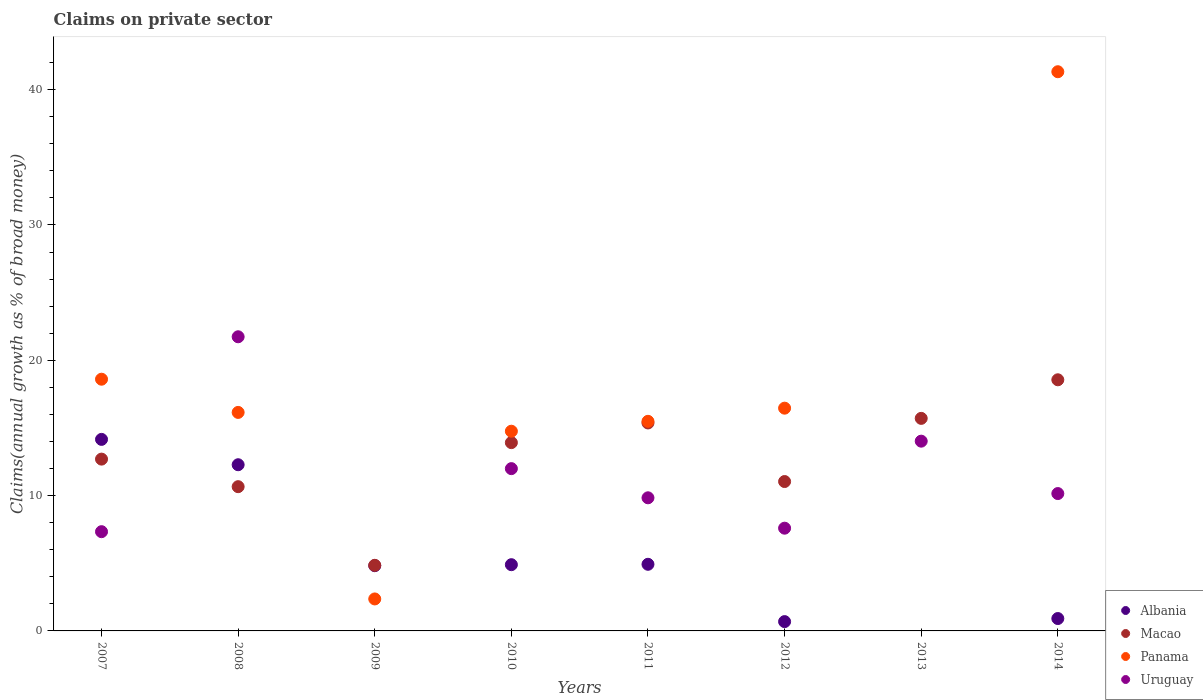What is the percentage of broad money claimed on private sector in Albania in 2014?
Keep it short and to the point. 0.92. Across all years, what is the maximum percentage of broad money claimed on private sector in Panama?
Keep it short and to the point. 41.32. Across all years, what is the minimum percentage of broad money claimed on private sector in Albania?
Ensure brevity in your answer.  0. In which year was the percentage of broad money claimed on private sector in Panama maximum?
Provide a short and direct response. 2014. What is the total percentage of broad money claimed on private sector in Albania in the graph?
Your answer should be very brief. 42.68. What is the difference between the percentage of broad money claimed on private sector in Macao in 2009 and that in 2011?
Provide a succinct answer. -10.52. What is the difference between the percentage of broad money claimed on private sector in Uruguay in 2012 and the percentage of broad money claimed on private sector in Albania in 2010?
Offer a terse response. 2.7. What is the average percentage of broad money claimed on private sector in Albania per year?
Make the answer very short. 5.33. In the year 2008, what is the difference between the percentage of broad money claimed on private sector in Uruguay and percentage of broad money claimed on private sector in Albania?
Ensure brevity in your answer.  9.46. In how many years, is the percentage of broad money claimed on private sector in Albania greater than 28 %?
Your response must be concise. 0. What is the ratio of the percentage of broad money claimed on private sector in Albania in 2009 to that in 2014?
Ensure brevity in your answer.  5.27. Is the percentage of broad money claimed on private sector in Panama in 2011 less than that in 2014?
Offer a terse response. Yes. What is the difference between the highest and the second highest percentage of broad money claimed on private sector in Albania?
Keep it short and to the point. 1.87. What is the difference between the highest and the lowest percentage of broad money claimed on private sector in Albania?
Give a very brief answer. 14.15. Does the percentage of broad money claimed on private sector in Albania monotonically increase over the years?
Your answer should be compact. No. Is the percentage of broad money claimed on private sector in Uruguay strictly less than the percentage of broad money claimed on private sector in Albania over the years?
Provide a succinct answer. No. How many years are there in the graph?
Ensure brevity in your answer.  8. Does the graph contain any zero values?
Provide a succinct answer. Yes. Does the graph contain grids?
Make the answer very short. No. How are the legend labels stacked?
Make the answer very short. Vertical. What is the title of the graph?
Provide a short and direct response. Claims on private sector. Does "Uruguay" appear as one of the legend labels in the graph?
Offer a terse response. Yes. What is the label or title of the Y-axis?
Your answer should be very brief. Claims(annual growth as % of broad money). What is the Claims(annual growth as % of broad money) in Albania in 2007?
Provide a succinct answer. 14.15. What is the Claims(annual growth as % of broad money) of Macao in 2007?
Keep it short and to the point. 12.7. What is the Claims(annual growth as % of broad money) of Panama in 2007?
Provide a succinct answer. 18.6. What is the Claims(annual growth as % of broad money) in Uruguay in 2007?
Your answer should be very brief. 7.33. What is the Claims(annual growth as % of broad money) of Albania in 2008?
Provide a short and direct response. 12.28. What is the Claims(annual growth as % of broad money) in Macao in 2008?
Keep it short and to the point. 10.66. What is the Claims(annual growth as % of broad money) of Panama in 2008?
Your answer should be compact. 16.15. What is the Claims(annual growth as % of broad money) of Uruguay in 2008?
Provide a succinct answer. 21.74. What is the Claims(annual growth as % of broad money) in Albania in 2009?
Give a very brief answer. 4.82. What is the Claims(annual growth as % of broad money) in Macao in 2009?
Give a very brief answer. 4.85. What is the Claims(annual growth as % of broad money) of Panama in 2009?
Offer a very short reply. 2.36. What is the Claims(annual growth as % of broad money) of Albania in 2010?
Your answer should be very brief. 4.89. What is the Claims(annual growth as % of broad money) in Macao in 2010?
Provide a short and direct response. 13.91. What is the Claims(annual growth as % of broad money) of Panama in 2010?
Provide a short and direct response. 14.76. What is the Claims(annual growth as % of broad money) of Uruguay in 2010?
Make the answer very short. 11.99. What is the Claims(annual growth as % of broad money) of Albania in 2011?
Keep it short and to the point. 4.92. What is the Claims(annual growth as % of broad money) in Macao in 2011?
Offer a terse response. 15.37. What is the Claims(annual growth as % of broad money) in Panama in 2011?
Make the answer very short. 15.49. What is the Claims(annual growth as % of broad money) in Uruguay in 2011?
Offer a very short reply. 9.84. What is the Claims(annual growth as % of broad money) of Albania in 2012?
Make the answer very short. 0.69. What is the Claims(annual growth as % of broad money) in Macao in 2012?
Your response must be concise. 11.04. What is the Claims(annual growth as % of broad money) of Panama in 2012?
Provide a succinct answer. 16.46. What is the Claims(annual growth as % of broad money) of Uruguay in 2012?
Ensure brevity in your answer.  7.59. What is the Claims(annual growth as % of broad money) of Albania in 2013?
Give a very brief answer. 0. What is the Claims(annual growth as % of broad money) in Macao in 2013?
Your response must be concise. 15.71. What is the Claims(annual growth as % of broad money) of Uruguay in 2013?
Your answer should be compact. 14.02. What is the Claims(annual growth as % of broad money) of Albania in 2014?
Your answer should be compact. 0.92. What is the Claims(annual growth as % of broad money) in Macao in 2014?
Give a very brief answer. 18.56. What is the Claims(annual growth as % of broad money) in Panama in 2014?
Your answer should be very brief. 41.32. What is the Claims(annual growth as % of broad money) in Uruguay in 2014?
Your answer should be compact. 10.15. Across all years, what is the maximum Claims(annual growth as % of broad money) in Albania?
Offer a very short reply. 14.15. Across all years, what is the maximum Claims(annual growth as % of broad money) of Macao?
Provide a short and direct response. 18.56. Across all years, what is the maximum Claims(annual growth as % of broad money) in Panama?
Offer a terse response. 41.32. Across all years, what is the maximum Claims(annual growth as % of broad money) of Uruguay?
Provide a succinct answer. 21.74. Across all years, what is the minimum Claims(annual growth as % of broad money) of Macao?
Provide a short and direct response. 4.85. Across all years, what is the minimum Claims(annual growth as % of broad money) in Uruguay?
Make the answer very short. 0. What is the total Claims(annual growth as % of broad money) of Albania in the graph?
Provide a succinct answer. 42.68. What is the total Claims(annual growth as % of broad money) of Macao in the graph?
Provide a succinct answer. 102.79. What is the total Claims(annual growth as % of broad money) in Panama in the graph?
Your answer should be very brief. 125.14. What is the total Claims(annual growth as % of broad money) of Uruguay in the graph?
Offer a very short reply. 82.67. What is the difference between the Claims(annual growth as % of broad money) in Albania in 2007 and that in 2008?
Offer a very short reply. 1.87. What is the difference between the Claims(annual growth as % of broad money) in Macao in 2007 and that in 2008?
Your response must be concise. 2.04. What is the difference between the Claims(annual growth as % of broad money) in Panama in 2007 and that in 2008?
Provide a short and direct response. 2.45. What is the difference between the Claims(annual growth as % of broad money) in Uruguay in 2007 and that in 2008?
Give a very brief answer. -14.4. What is the difference between the Claims(annual growth as % of broad money) in Albania in 2007 and that in 2009?
Your answer should be very brief. 9.33. What is the difference between the Claims(annual growth as % of broad money) of Macao in 2007 and that in 2009?
Your response must be concise. 7.85. What is the difference between the Claims(annual growth as % of broad money) in Panama in 2007 and that in 2009?
Offer a terse response. 16.24. What is the difference between the Claims(annual growth as % of broad money) in Albania in 2007 and that in 2010?
Make the answer very short. 9.26. What is the difference between the Claims(annual growth as % of broad money) in Macao in 2007 and that in 2010?
Your answer should be compact. -1.22. What is the difference between the Claims(annual growth as % of broad money) of Panama in 2007 and that in 2010?
Keep it short and to the point. 3.84. What is the difference between the Claims(annual growth as % of broad money) in Uruguay in 2007 and that in 2010?
Your answer should be very brief. -4.66. What is the difference between the Claims(annual growth as % of broad money) of Albania in 2007 and that in 2011?
Provide a short and direct response. 9.23. What is the difference between the Claims(annual growth as % of broad money) of Macao in 2007 and that in 2011?
Give a very brief answer. -2.67. What is the difference between the Claims(annual growth as % of broad money) of Panama in 2007 and that in 2011?
Make the answer very short. 3.11. What is the difference between the Claims(annual growth as % of broad money) in Uruguay in 2007 and that in 2011?
Offer a very short reply. -2.5. What is the difference between the Claims(annual growth as % of broad money) in Albania in 2007 and that in 2012?
Make the answer very short. 13.47. What is the difference between the Claims(annual growth as % of broad money) of Macao in 2007 and that in 2012?
Give a very brief answer. 1.66. What is the difference between the Claims(annual growth as % of broad money) in Panama in 2007 and that in 2012?
Offer a very short reply. 2.14. What is the difference between the Claims(annual growth as % of broad money) in Uruguay in 2007 and that in 2012?
Ensure brevity in your answer.  -0.26. What is the difference between the Claims(annual growth as % of broad money) of Macao in 2007 and that in 2013?
Offer a terse response. -3.01. What is the difference between the Claims(annual growth as % of broad money) in Uruguay in 2007 and that in 2013?
Provide a succinct answer. -6.69. What is the difference between the Claims(annual growth as % of broad money) in Albania in 2007 and that in 2014?
Your answer should be compact. 13.24. What is the difference between the Claims(annual growth as % of broad money) in Macao in 2007 and that in 2014?
Your answer should be very brief. -5.86. What is the difference between the Claims(annual growth as % of broad money) in Panama in 2007 and that in 2014?
Provide a succinct answer. -22.72. What is the difference between the Claims(annual growth as % of broad money) of Uruguay in 2007 and that in 2014?
Keep it short and to the point. -2.82. What is the difference between the Claims(annual growth as % of broad money) in Albania in 2008 and that in 2009?
Your answer should be compact. 7.46. What is the difference between the Claims(annual growth as % of broad money) in Macao in 2008 and that in 2009?
Give a very brief answer. 5.81. What is the difference between the Claims(annual growth as % of broad money) in Panama in 2008 and that in 2009?
Offer a very short reply. 13.78. What is the difference between the Claims(annual growth as % of broad money) in Albania in 2008 and that in 2010?
Provide a succinct answer. 7.39. What is the difference between the Claims(annual growth as % of broad money) in Macao in 2008 and that in 2010?
Ensure brevity in your answer.  -3.25. What is the difference between the Claims(annual growth as % of broad money) of Panama in 2008 and that in 2010?
Make the answer very short. 1.39. What is the difference between the Claims(annual growth as % of broad money) of Uruguay in 2008 and that in 2010?
Offer a terse response. 9.74. What is the difference between the Claims(annual growth as % of broad money) in Albania in 2008 and that in 2011?
Your answer should be compact. 7.36. What is the difference between the Claims(annual growth as % of broad money) of Macao in 2008 and that in 2011?
Your response must be concise. -4.71. What is the difference between the Claims(annual growth as % of broad money) in Panama in 2008 and that in 2011?
Ensure brevity in your answer.  0.66. What is the difference between the Claims(annual growth as % of broad money) in Uruguay in 2008 and that in 2011?
Offer a terse response. 11.9. What is the difference between the Claims(annual growth as % of broad money) in Albania in 2008 and that in 2012?
Ensure brevity in your answer.  11.59. What is the difference between the Claims(annual growth as % of broad money) of Macao in 2008 and that in 2012?
Ensure brevity in your answer.  -0.38. What is the difference between the Claims(annual growth as % of broad money) in Panama in 2008 and that in 2012?
Provide a short and direct response. -0.31. What is the difference between the Claims(annual growth as % of broad money) of Uruguay in 2008 and that in 2012?
Your answer should be compact. 14.14. What is the difference between the Claims(annual growth as % of broad money) of Macao in 2008 and that in 2013?
Provide a succinct answer. -5.05. What is the difference between the Claims(annual growth as % of broad money) in Uruguay in 2008 and that in 2013?
Offer a very short reply. 7.71. What is the difference between the Claims(annual growth as % of broad money) in Albania in 2008 and that in 2014?
Offer a terse response. 11.37. What is the difference between the Claims(annual growth as % of broad money) of Macao in 2008 and that in 2014?
Ensure brevity in your answer.  -7.9. What is the difference between the Claims(annual growth as % of broad money) of Panama in 2008 and that in 2014?
Your response must be concise. -25.18. What is the difference between the Claims(annual growth as % of broad money) of Uruguay in 2008 and that in 2014?
Keep it short and to the point. 11.59. What is the difference between the Claims(annual growth as % of broad money) of Albania in 2009 and that in 2010?
Ensure brevity in your answer.  -0.07. What is the difference between the Claims(annual growth as % of broad money) in Macao in 2009 and that in 2010?
Ensure brevity in your answer.  -9.07. What is the difference between the Claims(annual growth as % of broad money) of Panama in 2009 and that in 2010?
Keep it short and to the point. -12.39. What is the difference between the Claims(annual growth as % of broad money) of Albania in 2009 and that in 2011?
Offer a terse response. -0.1. What is the difference between the Claims(annual growth as % of broad money) of Macao in 2009 and that in 2011?
Give a very brief answer. -10.52. What is the difference between the Claims(annual growth as % of broad money) in Panama in 2009 and that in 2011?
Provide a short and direct response. -13.13. What is the difference between the Claims(annual growth as % of broad money) of Albania in 2009 and that in 2012?
Keep it short and to the point. 4.13. What is the difference between the Claims(annual growth as % of broad money) of Macao in 2009 and that in 2012?
Offer a terse response. -6.19. What is the difference between the Claims(annual growth as % of broad money) of Panama in 2009 and that in 2012?
Keep it short and to the point. -14.1. What is the difference between the Claims(annual growth as % of broad money) in Macao in 2009 and that in 2013?
Your answer should be very brief. -10.86. What is the difference between the Claims(annual growth as % of broad money) of Albania in 2009 and that in 2014?
Your answer should be compact. 3.91. What is the difference between the Claims(annual growth as % of broad money) of Macao in 2009 and that in 2014?
Provide a short and direct response. -13.71. What is the difference between the Claims(annual growth as % of broad money) of Panama in 2009 and that in 2014?
Offer a terse response. -38.96. What is the difference between the Claims(annual growth as % of broad money) in Albania in 2010 and that in 2011?
Keep it short and to the point. -0.03. What is the difference between the Claims(annual growth as % of broad money) in Macao in 2010 and that in 2011?
Make the answer very short. -1.45. What is the difference between the Claims(annual growth as % of broad money) in Panama in 2010 and that in 2011?
Provide a short and direct response. -0.73. What is the difference between the Claims(annual growth as % of broad money) of Uruguay in 2010 and that in 2011?
Your response must be concise. 2.16. What is the difference between the Claims(annual growth as % of broad money) in Albania in 2010 and that in 2012?
Make the answer very short. 4.21. What is the difference between the Claims(annual growth as % of broad money) of Macao in 2010 and that in 2012?
Make the answer very short. 2.88. What is the difference between the Claims(annual growth as % of broad money) of Panama in 2010 and that in 2012?
Provide a short and direct response. -1.7. What is the difference between the Claims(annual growth as % of broad money) of Uruguay in 2010 and that in 2012?
Offer a very short reply. 4.4. What is the difference between the Claims(annual growth as % of broad money) of Macao in 2010 and that in 2013?
Give a very brief answer. -1.79. What is the difference between the Claims(annual growth as % of broad money) in Uruguay in 2010 and that in 2013?
Provide a succinct answer. -2.03. What is the difference between the Claims(annual growth as % of broad money) in Albania in 2010 and that in 2014?
Make the answer very short. 3.98. What is the difference between the Claims(annual growth as % of broad money) in Macao in 2010 and that in 2014?
Your answer should be very brief. -4.64. What is the difference between the Claims(annual growth as % of broad money) in Panama in 2010 and that in 2014?
Provide a succinct answer. -26.57. What is the difference between the Claims(annual growth as % of broad money) in Uruguay in 2010 and that in 2014?
Give a very brief answer. 1.84. What is the difference between the Claims(annual growth as % of broad money) in Albania in 2011 and that in 2012?
Keep it short and to the point. 4.24. What is the difference between the Claims(annual growth as % of broad money) in Macao in 2011 and that in 2012?
Provide a succinct answer. 4.33. What is the difference between the Claims(annual growth as % of broad money) in Panama in 2011 and that in 2012?
Make the answer very short. -0.97. What is the difference between the Claims(annual growth as % of broad money) of Uruguay in 2011 and that in 2012?
Provide a short and direct response. 2.24. What is the difference between the Claims(annual growth as % of broad money) in Macao in 2011 and that in 2013?
Your response must be concise. -0.34. What is the difference between the Claims(annual growth as % of broad money) of Uruguay in 2011 and that in 2013?
Your answer should be very brief. -4.19. What is the difference between the Claims(annual growth as % of broad money) in Albania in 2011 and that in 2014?
Offer a very short reply. 4.01. What is the difference between the Claims(annual growth as % of broad money) in Macao in 2011 and that in 2014?
Offer a very short reply. -3.19. What is the difference between the Claims(annual growth as % of broad money) in Panama in 2011 and that in 2014?
Give a very brief answer. -25.83. What is the difference between the Claims(annual growth as % of broad money) in Uruguay in 2011 and that in 2014?
Your response must be concise. -0.31. What is the difference between the Claims(annual growth as % of broad money) in Macao in 2012 and that in 2013?
Offer a very short reply. -4.67. What is the difference between the Claims(annual growth as % of broad money) in Uruguay in 2012 and that in 2013?
Ensure brevity in your answer.  -6.43. What is the difference between the Claims(annual growth as % of broad money) in Albania in 2012 and that in 2014?
Ensure brevity in your answer.  -0.23. What is the difference between the Claims(annual growth as % of broad money) of Macao in 2012 and that in 2014?
Make the answer very short. -7.52. What is the difference between the Claims(annual growth as % of broad money) in Panama in 2012 and that in 2014?
Keep it short and to the point. -24.86. What is the difference between the Claims(annual growth as % of broad money) of Uruguay in 2012 and that in 2014?
Ensure brevity in your answer.  -2.56. What is the difference between the Claims(annual growth as % of broad money) of Macao in 2013 and that in 2014?
Provide a succinct answer. -2.85. What is the difference between the Claims(annual growth as % of broad money) of Uruguay in 2013 and that in 2014?
Provide a succinct answer. 3.87. What is the difference between the Claims(annual growth as % of broad money) in Albania in 2007 and the Claims(annual growth as % of broad money) in Macao in 2008?
Provide a short and direct response. 3.5. What is the difference between the Claims(annual growth as % of broad money) in Albania in 2007 and the Claims(annual growth as % of broad money) in Panama in 2008?
Ensure brevity in your answer.  -1.99. What is the difference between the Claims(annual growth as % of broad money) of Albania in 2007 and the Claims(annual growth as % of broad money) of Uruguay in 2008?
Provide a short and direct response. -7.58. What is the difference between the Claims(annual growth as % of broad money) in Macao in 2007 and the Claims(annual growth as % of broad money) in Panama in 2008?
Your answer should be very brief. -3.45. What is the difference between the Claims(annual growth as % of broad money) of Macao in 2007 and the Claims(annual growth as % of broad money) of Uruguay in 2008?
Make the answer very short. -9.04. What is the difference between the Claims(annual growth as % of broad money) in Panama in 2007 and the Claims(annual growth as % of broad money) in Uruguay in 2008?
Offer a terse response. -3.14. What is the difference between the Claims(annual growth as % of broad money) in Albania in 2007 and the Claims(annual growth as % of broad money) in Macao in 2009?
Your answer should be very brief. 9.31. What is the difference between the Claims(annual growth as % of broad money) in Albania in 2007 and the Claims(annual growth as % of broad money) in Panama in 2009?
Give a very brief answer. 11.79. What is the difference between the Claims(annual growth as % of broad money) of Macao in 2007 and the Claims(annual growth as % of broad money) of Panama in 2009?
Keep it short and to the point. 10.33. What is the difference between the Claims(annual growth as % of broad money) in Albania in 2007 and the Claims(annual growth as % of broad money) in Macao in 2010?
Your answer should be very brief. 0.24. What is the difference between the Claims(annual growth as % of broad money) in Albania in 2007 and the Claims(annual growth as % of broad money) in Panama in 2010?
Your answer should be compact. -0.6. What is the difference between the Claims(annual growth as % of broad money) in Albania in 2007 and the Claims(annual growth as % of broad money) in Uruguay in 2010?
Offer a very short reply. 2.16. What is the difference between the Claims(annual growth as % of broad money) in Macao in 2007 and the Claims(annual growth as % of broad money) in Panama in 2010?
Provide a succinct answer. -2.06. What is the difference between the Claims(annual growth as % of broad money) in Macao in 2007 and the Claims(annual growth as % of broad money) in Uruguay in 2010?
Provide a short and direct response. 0.7. What is the difference between the Claims(annual growth as % of broad money) of Panama in 2007 and the Claims(annual growth as % of broad money) of Uruguay in 2010?
Provide a succinct answer. 6.61. What is the difference between the Claims(annual growth as % of broad money) in Albania in 2007 and the Claims(annual growth as % of broad money) in Macao in 2011?
Provide a succinct answer. -1.21. What is the difference between the Claims(annual growth as % of broad money) of Albania in 2007 and the Claims(annual growth as % of broad money) of Panama in 2011?
Keep it short and to the point. -1.33. What is the difference between the Claims(annual growth as % of broad money) of Albania in 2007 and the Claims(annual growth as % of broad money) of Uruguay in 2011?
Offer a very short reply. 4.32. What is the difference between the Claims(annual growth as % of broad money) of Macao in 2007 and the Claims(annual growth as % of broad money) of Panama in 2011?
Make the answer very short. -2.79. What is the difference between the Claims(annual growth as % of broad money) of Macao in 2007 and the Claims(annual growth as % of broad money) of Uruguay in 2011?
Ensure brevity in your answer.  2.86. What is the difference between the Claims(annual growth as % of broad money) of Panama in 2007 and the Claims(annual growth as % of broad money) of Uruguay in 2011?
Ensure brevity in your answer.  8.76. What is the difference between the Claims(annual growth as % of broad money) in Albania in 2007 and the Claims(annual growth as % of broad money) in Macao in 2012?
Keep it short and to the point. 3.12. What is the difference between the Claims(annual growth as % of broad money) of Albania in 2007 and the Claims(annual growth as % of broad money) of Panama in 2012?
Provide a short and direct response. -2.31. What is the difference between the Claims(annual growth as % of broad money) of Albania in 2007 and the Claims(annual growth as % of broad money) of Uruguay in 2012?
Provide a short and direct response. 6.56. What is the difference between the Claims(annual growth as % of broad money) in Macao in 2007 and the Claims(annual growth as % of broad money) in Panama in 2012?
Make the answer very short. -3.77. What is the difference between the Claims(annual growth as % of broad money) in Macao in 2007 and the Claims(annual growth as % of broad money) in Uruguay in 2012?
Your response must be concise. 5.1. What is the difference between the Claims(annual growth as % of broad money) in Panama in 2007 and the Claims(annual growth as % of broad money) in Uruguay in 2012?
Offer a very short reply. 11.01. What is the difference between the Claims(annual growth as % of broad money) in Albania in 2007 and the Claims(annual growth as % of broad money) in Macao in 2013?
Offer a very short reply. -1.55. What is the difference between the Claims(annual growth as % of broad money) in Albania in 2007 and the Claims(annual growth as % of broad money) in Uruguay in 2013?
Make the answer very short. 0.13. What is the difference between the Claims(annual growth as % of broad money) of Macao in 2007 and the Claims(annual growth as % of broad money) of Uruguay in 2013?
Provide a succinct answer. -1.33. What is the difference between the Claims(annual growth as % of broad money) of Panama in 2007 and the Claims(annual growth as % of broad money) of Uruguay in 2013?
Your response must be concise. 4.58. What is the difference between the Claims(annual growth as % of broad money) of Albania in 2007 and the Claims(annual growth as % of broad money) of Macao in 2014?
Keep it short and to the point. -4.4. What is the difference between the Claims(annual growth as % of broad money) in Albania in 2007 and the Claims(annual growth as % of broad money) in Panama in 2014?
Your response must be concise. -27.17. What is the difference between the Claims(annual growth as % of broad money) in Albania in 2007 and the Claims(annual growth as % of broad money) in Uruguay in 2014?
Your answer should be very brief. 4. What is the difference between the Claims(annual growth as % of broad money) in Macao in 2007 and the Claims(annual growth as % of broad money) in Panama in 2014?
Make the answer very short. -28.63. What is the difference between the Claims(annual growth as % of broad money) in Macao in 2007 and the Claims(annual growth as % of broad money) in Uruguay in 2014?
Make the answer very short. 2.55. What is the difference between the Claims(annual growth as % of broad money) in Panama in 2007 and the Claims(annual growth as % of broad money) in Uruguay in 2014?
Your response must be concise. 8.45. What is the difference between the Claims(annual growth as % of broad money) of Albania in 2008 and the Claims(annual growth as % of broad money) of Macao in 2009?
Provide a succinct answer. 7.43. What is the difference between the Claims(annual growth as % of broad money) of Albania in 2008 and the Claims(annual growth as % of broad money) of Panama in 2009?
Keep it short and to the point. 9.92. What is the difference between the Claims(annual growth as % of broad money) in Macao in 2008 and the Claims(annual growth as % of broad money) in Panama in 2009?
Make the answer very short. 8.3. What is the difference between the Claims(annual growth as % of broad money) of Albania in 2008 and the Claims(annual growth as % of broad money) of Macao in 2010?
Your answer should be compact. -1.63. What is the difference between the Claims(annual growth as % of broad money) in Albania in 2008 and the Claims(annual growth as % of broad money) in Panama in 2010?
Give a very brief answer. -2.48. What is the difference between the Claims(annual growth as % of broad money) of Albania in 2008 and the Claims(annual growth as % of broad money) of Uruguay in 2010?
Offer a terse response. 0.29. What is the difference between the Claims(annual growth as % of broad money) of Macao in 2008 and the Claims(annual growth as % of broad money) of Panama in 2010?
Offer a terse response. -4.1. What is the difference between the Claims(annual growth as % of broad money) in Macao in 2008 and the Claims(annual growth as % of broad money) in Uruguay in 2010?
Keep it short and to the point. -1.33. What is the difference between the Claims(annual growth as % of broad money) in Panama in 2008 and the Claims(annual growth as % of broad money) in Uruguay in 2010?
Your answer should be compact. 4.16. What is the difference between the Claims(annual growth as % of broad money) in Albania in 2008 and the Claims(annual growth as % of broad money) in Macao in 2011?
Ensure brevity in your answer.  -3.09. What is the difference between the Claims(annual growth as % of broad money) in Albania in 2008 and the Claims(annual growth as % of broad money) in Panama in 2011?
Your answer should be compact. -3.21. What is the difference between the Claims(annual growth as % of broad money) of Albania in 2008 and the Claims(annual growth as % of broad money) of Uruguay in 2011?
Offer a terse response. 2.44. What is the difference between the Claims(annual growth as % of broad money) of Macao in 2008 and the Claims(annual growth as % of broad money) of Panama in 2011?
Offer a terse response. -4.83. What is the difference between the Claims(annual growth as % of broad money) in Macao in 2008 and the Claims(annual growth as % of broad money) in Uruguay in 2011?
Keep it short and to the point. 0.82. What is the difference between the Claims(annual growth as % of broad money) of Panama in 2008 and the Claims(annual growth as % of broad money) of Uruguay in 2011?
Offer a very short reply. 6.31. What is the difference between the Claims(annual growth as % of broad money) of Albania in 2008 and the Claims(annual growth as % of broad money) of Macao in 2012?
Keep it short and to the point. 1.24. What is the difference between the Claims(annual growth as % of broad money) of Albania in 2008 and the Claims(annual growth as % of broad money) of Panama in 2012?
Provide a short and direct response. -4.18. What is the difference between the Claims(annual growth as % of broad money) in Albania in 2008 and the Claims(annual growth as % of broad money) in Uruguay in 2012?
Offer a very short reply. 4.69. What is the difference between the Claims(annual growth as % of broad money) in Macao in 2008 and the Claims(annual growth as % of broad money) in Panama in 2012?
Your answer should be very brief. -5.8. What is the difference between the Claims(annual growth as % of broad money) in Macao in 2008 and the Claims(annual growth as % of broad money) in Uruguay in 2012?
Keep it short and to the point. 3.07. What is the difference between the Claims(annual growth as % of broad money) in Panama in 2008 and the Claims(annual growth as % of broad money) in Uruguay in 2012?
Offer a very short reply. 8.56. What is the difference between the Claims(annual growth as % of broad money) in Albania in 2008 and the Claims(annual growth as % of broad money) in Macao in 2013?
Provide a short and direct response. -3.43. What is the difference between the Claims(annual growth as % of broad money) of Albania in 2008 and the Claims(annual growth as % of broad money) of Uruguay in 2013?
Make the answer very short. -1.74. What is the difference between the Claims(annual growth as % of broad money) in Macao in 2008 and the Claims(annual growth as % of broad money) in Uruguay in 2013?
Your answer should be very brief. -3.36. What is the difference between the Claims(annual growth as % of broad money) in Panama in 2008 and the Claims(annual growth as % of broad money) in Uruguay in 2013?
Make the answer very short. 2.12. What is the difference between the Claims(annual growth as % of broad money) in Albania in 2008 and the Claims(annual growth as % of broad money) in Macao in 2014?
Provide a succinct answer. -6.28. What is the difference between the Claims(annual growth as % of broad money) in Albania in 2008 and the Claims(annual growth as % of broad money) in Panama in 2014?
Your answer should be very brief. -29.04. What is the difference between the Claims(annual growth as % of broad money) of Albania in 2008 and the Claims(annual growth as % of broad money) of Uruguay in 2014?
Offer a terse response. 2.13. What is the difference between the Claims(annual growth as % of broad money) in Macao in 2008 and the Claims(annual growth as % of broad money) in Panama in 2014?
Offer a very short reply. -30.66. What is the difference between the Claims(annual growth as % of broad money) of Macao in 2008 and the Claims(annual growth as % of broad money) of Uruguay in 2014?
Provide a short and direct response. 0.51. What is the difference between the Claims(annual growth as % of broad money) of Panama in 2008 and the Claims(annual growth as % of broad money) of Uruguay in 2014?
Give a very brief answer. 6. What is the difference between the Claims(annual growth as % of broad money) of Albania in 2009 and the Claims(annual growth as % of broad money) of Macao in 2010?
Provide a succinct answer. -9.09. What is the difference between the Claims(annual growth as % of broad money) of Albania in 2009 and the Claims(annual growth as % of broad money) of Panama in 2010?
Your response must be concise. -9.94. What is the difference between the Claims(annual growth as % of broad money) of Albania in 2009 and the Claims(annual growth as % of broad money) of Uruguay in 2010?
Offer a very short reply. -7.17. What is the difference between the Claims(annual growth as % of broad money) of Macao in 2009 and the Claims(annual growth as % of broad money) of Panama in 2010?
Provide a succinct answer. -9.91. What is the difference between the Claims(annual growth as % of broad money) in Macao in 2009 and the Claims(annual growth as % of broad money) in Uruguay in 2010?
Offer a terse response. -7.14. What is the difference between the Claims(annual growth as % of broad money) in Panama in 2009 and the Claims(annual growth as % of broad money) in Uruguay in 2010?
Give a very brief answer. -9.63. What is the difference between the Claims(annual growth as % of broad money) in Albania in 2009 and the Claims(annual growth as % of broad money) in Macao in 2011?
Keep it short and to the point. -10.55. What is the difference between the Claims(annual growth as % of broad money) in Albania in 2009 and the Claims(annual growth as % of broad money) in Panama in 2011?
Make the answer very short. -10.67. What is the difference between the Claims(annual growth as % of broad money) in Albania in 2009 and the Claims(annual growth as % of broad money) in Uruguay in 2011?
Provide a short and direct response. -5.02. What is the difference between the Claims(annual growth as % of broad money) of Macao in 2009 and the Claims(annual growth as % of broad money) of Panama in 2011?
Make the answer very short. -10.64. What is the difference between the Claims(annual growth as % of broad money) of Macao in 2009 and the Claims(annual growth as % of broad money) of Uruguay in 2011?
Provide a succinct answer. -4.99. What is the difference between the Claims(annual growth as % of broad money) of Panama in 2009 and the Claims(annual growth as % of broad money) of Uruguay in 2011?
Make the answer very short. -7.47. What is the difference between the Claims(annual growth as % of broad money) of Albania in 2009 and the Claims(annual growth as % of broad money) of Macao in 2012?
Ensure brevity in your answer.  -6.22. What is the difference between the Claims(annual growth as % of broad money) in Albania in 2009 and the Claims(annual growth as % of broad money) in Panama in 2012?
Provide a short and direct response. -11.64. What is the difference between the Claims(annual growth as % of broad money) in Albania in 2009 and the Claims(annual growth as % of broad money) in Uruguay in 2012?
Keep it short and to the point. -2.77. What is the difference between the Claims(annual growth as % of broad money) in Macao in 2009 and the Claims(annual growth as % of broad money) in Panama in 2012?
Give a very brief answer. -11.61. What is the difference between the Claims(annual growth as % of broad money) of Macao in 2009 and the Claims(annual growth as % of broad money) of Uruguay in 2012?
Provide a succinct answer. -2.74. What is the difference between the Claims(annual growth as % of broad money) of Panama in 2009 and the Claims(annual growth as % of broad money) of Uruguay in 2012?
Your answer should be compact. -5.23. What is the difference between the Claims(annual growth as % of broad money) of Albania in 2009 and the Claims(annual growth as % of broad money) of Macao in 2013?
Provide a succinct answer. -10.89. What is the difference between the Claims(annual growth as % of broad money) of Albania in 2009 and the Claims(annual growth as % of broad money) of Uruguay in 2013?
Offer a terse response. -9.2. What is the difference between the Claims(annual growth as % of broad money) in Macao in 2009 and the Claims(annual growth as % of broad money) in Uruguay in 2013?
Ensure brevity in your answer.  -9.17. What is the difference between the Claims(annual growth as % of broad money) in Panama in 2009 and the Claims(annual growth as % of broad money) in Uruguay in 2013?
Ensure brevity in your answer.  -11.66. What is the difference between the Claims(annual growth as % of broad money) in Albania in 2009 and the Claims(annual growth as % of broad money) in Macao in 2014?
Offer a very short reply. -13.74. What is the difference between the Claims(annual growth as % of broad money) of Albania in 2009 and the Claims(annual growth as % of broad money) of Panama in 2014?
Make the answer very short. -36.5. What is the difference between the Claims(annual growth as % of broad money) of Albania in 2009 and the Claims(annual growth as % of broad money) of Uruguay in 2014?
Ensure brevity in your answer.  -5.33. What is the difference between the Claims(annual growth as % of broad money) in Macao in 2009 and the Claims(annual growth as % of broad money) in Panama in 2014?
Your answer should be very brief. -36.48. What is the difference between the Claims(annual growth as % of broad money) of Macao in 2009 and the Claims(annual growth as % of broad money) of Uruguay in 2014?
Ensure brevity in your answer.  -5.3. What is the difference between the Claims(annual growth as % of broad money) in Panama in 2009 and the Claims(annual growth as % of broad money) in Uruguay in 2014?
Your response must be concise. -7.79. What is the difference between the Claims(annual growth as % of broad money) in Albania in 2010 and the Claims(annual growth as % of broad money) in Macao in 2011?
Your answer should be compact. -10.47. What is the difference between the Claims(annual growth as % of broad money) in Albania in 2010 and the Claims(annual growth as % of broad money) in Panama in 2011?
Keep it short and to the point. -10.59. What is the difference between the Claims(annual growth as % of broad money) in Albania in 2010 and the Claims(annual growth as % of broad money) in Uruguay in 2011?
Provide a succinct answer. -4.94. What is the difference between the Claims(annual growth as % of broad money) of Macao in 2010 and the Claims(annual growth as % of broad money) of Panama in 2011?
Provide a succinct answer. -1.57. What is the difference between the Claims(annual growth as % of broad money) in Macao in 2010 and the Claims(annual growth as % of broad money) in Uruguay in 2011?
Give a very brief answer. 4.08. What is the difference between the Claims(annual growth as % of broad money) in Panama in 2010 and the Claims(annual growth as % of broad money) in Uruguay in 2011?
Offer a terse response. 4.92. What is the difference between the Claims(annual growth as % of broad money) in Albania in 2010 and the Claims(annual growth as % of broad money) in Macao in 2012?
Offer a very short reply. -6.14. What is the difference between the Claims(annual growth as % of broad money) in Albania in 2010 and the Claims(annual growth as % of broad money) in Panama in 2012?
Provide a short and direct response. -11.57. What is the difference between the Claims(annual growth as % of broad money) of Albania in 2010 and the Claims(annual growth as % of broad money) of Uruguay in 2012?
Provide a short and direct response. -2.7. What is the difference between the Claims(annual growth as % of broad money) in Macao in 2010 and the Claims(annual growth as % of broad money) in Panama in 2012?
Ensure brevity in your answer.  -2.55. What is the difference between the Claims(annual growth as % of broad money) of Macao in 2010 and the Claims(annual growth as % of broad money) of Uruguay in 2012?
Provide a succinct answer. 6.32. What is the difference between the Claims(annual growth as % of broad money) of Panama in 2010 and the Claims(annual growth as % of broad money) of Uruguay in 2012?
Your answer should be compact. 7.17. What is the difference between the Claims(annual growth as % of broad money) in Albania in 2010 and the Claims(annual growth as % of broad money) in Macao in 2013?
Make the answer very short. -10.81. What is the difference between the Claims(annual growth as % of broad money) of Albania in 2010 and the Claims(annual growth as % of broad money) of Uruguay in 2013?
Your response must be concise. -9.13. What is the difference between the Claims(annual growth as % of broad money) of Macao in 2010 and the Claims(annual growth as % of broad money) of Uruguay in 2013?
Provide a succinct answer. -0.11. What is the difference between the Claims(annual growth as % of broad money) of Panama in 2010 and the Claims(annual growth as % of broad money) of Uruguay in 2013?
Your answer should be compact. 0.73. What is the difference between the Claims(annual growth as % of broad money) of Albania in 2010 and the Claims(annual growth as % of broad money) of Macao in 2014?
Your answer should be very brief. -13.66. What is the difference between the Claims(annual growth as % of broad money) of Albania in 2010 and the Claims(annual growth as % of broad money) of Panama in 2014?
Keep it short and to the point. -36.43. What is the difference between the Claims(annual growth as % of broad money) in Albania in 2010 and the Claims(annual growth as % of broad money) in Uruguay in 2014?
Offer a terse response. -5.26. What is the difference between the Claims(annual growth as % of broad money) in Macao in 2010 and the Claims(annual growth as % of broad money) in Panama in 2014?
Give a very brief answer. -27.41. What is the difference between the Claims(annual growth as % of broad money) of Macao in 2010 and the Claims(annual growth as % of broad money) of Uruguay in 2014?
Your answer should be compact. 3.76. What is the difference between the Claims(annual growth as % of broad money) of Panama in 2010 and the Claims(annual growth as % of broad money) of Uruguay in 2014?
Your response must be concise. 4.61. What is the difference between the Claims(annual growth as % of broad money) in Albania in 2011 and the Claims(annual growth as % of broad money) in Macao in 2012?
Give a very brief answer. -6.12. What is the difference between the Claims(annual growth as % of broad money) in Albania in 2011 and the Claims(annual growth as % of broad money) in Panama in 2012?
Provide a succinct answer. -11.54. What is the difference between the Claims(annual growth as % of broad money) of Albania in 2011 and the Claims(annual growth as % of broad money) of Uruguay in 2012?
Give a very brief answer. -2.67. What is the difference between the Claims(annual growth as % of broad money) in Macao in 2011 and the Claims(annual growth as % of broad money) in Panama in 2012?
Provide a short and direct response. -1.09. What is the difference between the Claims(annual growth as % of broad money) in Macao in 2011 and the Claims(annual growth as % of broad money) in Uruguay in 2012?
Offer a terse response. 7.78. What is the difference between the Claims(annual growth as % of broad money) of Panama in 2011 and the Claims(annual growth as % of broad money) of Uruguay in 2012?
Ensure brevity in your answer.  7.9. What is the difference between the Claims(annual growth as % of broad money) in Albania in 2011 and the Claims(annual growth as % of broad money) in Macao in 2013?
Keep it short and to the point. -10.78. What is the difference between the Claims(annual growth as % of broad money) of Albania in 2011 and the Claims(annual growth as % of broad money) of Uruguay in 2013?
Keep it short and to the point. -9.1. What is the difference between the Claims(annual growth as % of broad money) in Macao in 2011 and the Claims(annual growth as % of broad money) in Uruguay in 2013?
Provide a short and direct response. 1.35. What is the difference between the Claims(annual growth as % of broad money) of Panama in 2011 and the Claims(annual growth as % of broad money) of Uruguay in 2013?
Provide a short and direct response. 1.47. What is the difference between the Claims(annual growth as % of broad money) of Albania in 2011 and the Claims(annual growth as % of broad money) of Macao in 2014?
Provide a short and direct response. -13.63. What is the difference between the Claims(annual growth as % of broad money) of Albania in 2011 and the Claims(annual growth as % of broad money) of Panama in 2014?
Your response must be concise. -36.4. What is the difference between the Claims(annual growth as % of broad money) in Albania in 2011 and the Claims(annual growth as % of broad money) in Uruguay in 2014?
Provide a succinct answer. -5.23. What is the difference between the Claims(annual growth as % of broad money) in Macao in 2011 and the Claims(annual growth as % of broad money) in Panama in 2014?
Your answer should be very brief. -25.95. What is the difference between the Claims(annual growth as % of broad money) in Macao in 2011 and the Claims(annual growth as % of broad money) in Uruguay in 2014?
Give a very brief answer. 5.22. What is the difference between the Claims(annual growth as % of broad money) in Panama in 2011 and the Claims(annual growth as % of broad money) in Uruguay in 2014?
Your answer should be very brief. 5.34. What is the difference between the Claims(annual growth as % of broad money) of Albania in 2012 and the Claims(annual growth as % of broad money) of Macao in 2013?
Your answer should be compact. -15.02. What is the difference between the Claims(annual growth as % of broad money) of Albania in 2012 and the Claims(annual growth as % of broad money) of Uruguay in 2013?
Offer a terse response. -13.34. What is the difference between the Claims(annual growth as % of broad money) in Macao in 2012 and the Claims(annual growth as % of broad money) in Uruguay in 2013?
Keep it short and to the point. -2.98. What is the difference between the Claims(annual growth as % of broad money) in Panama in 2012 and the Claims(annual growth as % of broad money) in Uruguay in 2013?
Your answer should be very brief. 2.44. What is the difference between the Claims(annual growth as % of broad money) in Albania in 2012 and the Claims(annual growth as % of broad money) in Macao in 2014?
Offer a very short reply. -17.87. What is the difference between the Claims(annual growth as % of broad money) in Albania in 2012 and the Claims(annual growth as % of broad money) in Panama in 2014?
Ensure brevity in your answer.  -40.64. What is the difference between the Claims(annual growth as % of broad money) in Albania in 2012 and the Claims(annual growth as % of broad money) in Uruguay in 2014?
Your answer should be compact. -9.46. What is the difference between the Claims(annual growth as % of broad money) in Macao in 2012 and the Claims(annual growth as % of broad money) in Panama in 2014?
Your answer should be compact. -30.28. What is the difference between the Claims(annual growth as % of broad money) in Macao in 2012 and the Claims(annual growth as % of broad money) in Uruguay in 2014?
Offer a terse response. 0.89. What is the difference between the Claims(annual growth as % of broad money) in Panama in 2012 and the Claims(annual growth as % of broad money) in Uruguay in 2014?
Your answer should be very brief. 6.31. What is the difference between the Claims(annual growth as % of broad money) of Macao in 2013 and the Claims(annual growth as % of broad money) of Panama in 2014?
Make the answer very short. -25.62. What is the difference between the Claims(annual growth as % of broad money) in Macao in 2013 and the Claims(annual growth as % of broad money) in Uruguay in 2014?
Provide a succinct answer. 5.56. What is the average Claims(annual growth as % of broad money) in Albania per year?
Make the answer very short. 5.33. What is the average Claims(annual growth as % of broad money) of Macao per year?
Offer a terse response. 12.85. What is the average Claims(annual growth as % of broad money) in Panama per year?
Provide a short and direct response. 15.64. What is the average Claims(annual growth as % of broad money) of Uruguay per year?
Provide a short and direct response. 10.33. In the year 2007, what is the difference between the Claims(annual growth as % of broad money) of Albania and Claims(annual growth as % of broad money) of Macao?
Your response must be concise. 1.46. In the year 2007, what is the difference between the Claims(annual growth as % of broad money) of Albania and Claims(annual growth as % of broad money) of Panama?
Your response must be concise. -4.45. In the year 2007, what is the difference between the Claims(annual growth as % of broad money) in Albania and Claims(annual growth as % of broad money) in Uruguay?
Offer a very short reply. 6.82. In the year 2007, what is the difference between the Claims(annual growth as % of broad money) in Macao and Claims(annual growth as % of broad money) in Panama?
Offer a very short reply. -5.91. In the year 2007, what is the difference between the Claims(annual growth as % of broad money) of Macao and Claims(annual growth as % of broad money) of Uruguay?
Offer a terse response. 5.36. In the year 2007, what is the difference between the Claims(annual growth as % of broad money) of Panama and Claims(annual growth as % of broad money) of Uruguay?
Offer a terse response. 11.27. In the year 2008, what is the difference between the Claims(annual growth as % of broad money) of Albania and Claims(annual growth as % of broad money) of Macao?
Your response must be concise. 1.62. In the year 2008, what is the difference between the Claims(annual growth as % of broad money) of Albania and Claims(annual growth as % of broad money) of Panama?
Your answer should be compact. -3.87. In the year 2008, what is the difference between the Claims(annual growth as % of broad money) of Albania and Claims(annual growth as % of broad money) of Uruguay?
Give a very brief answer. -9.46. In the year 2008, what is the difference between the Claims(annual growth as % of broad money) of Macao and Claims(annual growth as % of broad money) of Panama?
Provide a short and direct response. -5.49. In the year 2008, what is the difference between the Claims(annual growth as % of broad money) of Macao and Claims(annual growth as % of broad money) of Uruguay?
Ensure brevity in your answer.  -11.08. In the year 2008, what is the difference between the Claims(annual growth as % of broad money) of Panama and Claims(annual growth as % of broad money) of Uruguay?
Your answer should be compact. -5.59. In the year 2009, what is the difference between the Claims(annual growth as % of broad money) of Albania and Claims(annual growth as % of broad money) of Macao?
Provide a succinct answer. -0.03. In the year 2009, what is the difference between the Claims(annual growth as % of broad money) in Albania and Claims(annual growth as % of broad money) in Panama?
Give a very brief answer. 2.46. In the year 2009, what is the difference between the Claims(annual growth as % of broad money) of Macao and Claims(annual growth as % of broad money) of Panama?
Your response must be concise. 2.49. In the year 2010, what is the difference between the Claims(annual growth as % of broad money) of Albania and Claims(annual growth as % of broad money) of Macao?
Offer a terse response. -9.02. In the year 2010, what is the difference between the Claims(annual growth as % of broad money) in Albania and Claims(annual growth as % of broad money) in Panama?
Your answer should be very brief. -9.86. In the year 2010, what is the difference between the Claims(annual growth as % of broad money) in Albania and Claims(annual growth as % of broad money) in Uruguay?
Give a very brief answer. -7.1. In the year 2010, what is the difference between the Claims(annual growth as % of broad money) of Macao and Claims(annual growth as % of broad money) of Panama?
Offer a very short reply. -0.84. In the year 2010, what is the difference between the Claims(annual growth as % of broad money) in Macao and Claims(annual growth as % of broad money) in Uruguay?
Provide a succinct answer. 1.92. In the year 2010, what is the difference between the Claims(annual growth as % of broad money) in Panama and Claims(annual growth as % of broad money) in Uruguay?
Provide a succinct answer. 2.77. In the year 2011, what is the difference between the Claims(annual growth as % of broad money) of Albania and Claims(annual growth as % of broad money) of Macao?
Offer a very short reply. -10.45. In the year 2011, what is the difference between the Claims(annual growth as % of broad money) in Albania and Claims(annual growth as % of broad money) in Panama?
Keep it short and to the point. -10.57. In the year 2011, what is the difference between the Claims(annual growth as % of broad money) in Albania and Claims(annual growth as % of broad money) in Uruguay?
Offer a terse response. -4.91. In the year 2011, what is the difference between the Claims(annual growth as % of broad money) in Macao and Claims(annual growth as % of broad money) in Panama?
Provide a succinct answer. -0.12. In the year 2011, what is the difference between the Claims(annual growth as % of broad money) of Macao and Claims(annual growth as % of broad money) of Uruguay?
Make the answer very short. 5.53. In the year 2011, what is the difference between the Claims(annual growth as % of broad money) in Panama and Claims(annual growth as % of broad money) in Uruguay?
Make the answer very short. 5.65. In the year 2012, what is the difference between the Claims(annual growth as % of broad money) in Albania and Claims(annual growth as % of broad money) in Macao?
Your response must be concise. -10.35. In the year 2012, what is the difference between the Claims(annual growth as % of broad money) of Albania and Claims(annual growth as % of broad money) of Panama?
Provide a short and direct response. -15.77. In the year 2012, what is the difference between the Claims(annual growth as % of broad money) of Albania and Claims(annual growth as % of broad money) of Uruguay?
Keep it short and to the point. -6.9. In the year 2012, what is the difference between the Claims(annual growth as % of broad money) in Macao and Claims(annual growth as % of broad money) in Panama?
Offer a terse response. -5.42. In the year 2012, what is the difference between the Claims(annual growth as % of broad money) of Macao and Claims(annual growth as % of broad money) of Uruguay?
Give a very brief answer. 3.45. In the year 2012, what is the difference between the Claims(annual growth as % of broad money) in Panama and Claims(annual growth as % of broad money) in Uruguay?
Your answer should be compact. 8.87. In the year 2013, what is the difference between the Claims(annual growth as % of broad money) of Macao and Claims(annual growth as % of broad money) of Uruguay?
Your answer should be compact. 1.68. In the year 2014, what is the difference between the Claims(annual growth as % of broad money) in Albania and Claims(annual growth as % of broad money) in Macao?
Provide a short and direct response. -17.64. In the year 2014, what is the difference between the Claims(annual growth as % of broad money) in Albania and Claims(annual growth as % of broad money) in Panama?
Make the answer very short. -40.41. In the year 2014, what is the difference between the Claims(annual growth as % of broad money) of Albania and Claims(annual growth as % of broad money) of Uruguay?
Offer a terse response. -9.24. In the year 2014, what is the difference between the Claims(annual growth as % of broad money) in Macao and Claims(annual growth as % of broad money) in Panama?
Keep it short and to the point. -22.77. In the year 2014, what is the difference between the Claims(annual growth as % of broad money) of Macao and Claims(annual growth as % of broad money) of Uruguay?
Keep it short and to the point. 8.41. In the year 2014, what is the difference between the Claims(annual growth as % of broad money) of Panama and Claims(annual growth as % of broad money) of Uruguay?
Your response must be concise. 31.17. What is the ratio of the Claims(annual growth as % of broad money) in Albania in 2007 to that in 2008?
Ensure brevity in your answer.  1.15. What is the ratio of the Claims(annual growth as % of broad money) of Macao in 2007 to that in 2008?
Give a very brief answer. 1.19. What is the ratio of the Claims(annual growth as % of broad money) of Panama in 2007 to that in 2008?
Offer a terse response. 1.15. What is the ratio of the Claims(annual growth as % of broad money) of Uruguay in 2007 to that in 2008?
Ensure brevity in your answer.  0.34. What is the ratio of the Claims(annual growth as % of broad money) of Albania in 2007 to that in 2009?
Give a very brief answer. 2.94. What is the ratio of the Claims(annual growth as % of broad money) of Macao in 2007 to that in 2009?
Offer a terse response. 2.62. What is the ratio of the Claims(annual growth as % of broad money) of Panama in 2007 to that in 2009?
Keep it short and to the point. 7.87. What is the ratio of the Claims(annual growth as % of broad money) of Albania in 2007 to that in 2010?
Keep it short and to the point. 2.89. What is the ratio of the Claims(annual growth as % of broad money) in Macao in 2007 to that in 2010?
Provide a succinct answer. 0.91. What is the ratio of the Claims(annual growth as % of broad money) of Panama in 2007 to that in 2010?
Offer a terse response. 1.26. What is the ratio of the Claims(annual growth as % of broad money) in Uruguay in 2007 to that in 2010?
Keep it short and to the point. 0.61. What is the ratio of the Claims(annual growth as % of broad money) of Albania in 2007 to that in 2011?
Offer a very short reply. 2.87. What is the ratio of the Claims(annual growth as % of broad money) of Macao in 2007 to that in 2011?
Your response must be concise. 0.83. What is the ratio of the Claims(annual growth as % of broad money) in Panama in 2007 to that in 2011?
Your answer should be very brief. 1.2. What is the ratio of the Claims(annual growth as % of broad money) of Uruguay in 2007 to that in 2011?
Offer a very short reply. 0.75. What is the ratio of the Claims(annual growth as % of broad money) of Albania in 2007 to that in 2012?
Give a very brief answer. 20.58. What is the ratio of the Claims(annual growth as % of broad money) in Macao in 2007 to that in 2012?
Your answer should be very brief. 1.15. What is the ratio of the Claims(annual growth as % of broad money) in Panama in 2007 to that in 2012?
Give a very brief answer. 1.13. What is the ratio of the Claims(annual growth as % of broad money) of Uruguay in 2007 to that in 2012?
Provide a succinct answer. 0.97. What is the ratio of the Claims(annual growth as % of broad money) in Macao in 2007 to that in 2013?
Your answer should be very brief. 0.81. What is the ratio of the Claims(annual growth as % of broad money) of Uruguay in 2007 to that in 2013?
Offer a very short reply. 0.52. What is the ratio of the Claims(annual growth as % of broad money) of Albania in 2007 to that in 2014?
Provide a short and direct response. 15.47. What is the ratio of the Claims(annual growth as % of broad money) of Macao in 2007 to that in 2014?
Keep it short and to the point. 0.68. What is the ratio of the Claims(annual growth as % of broad money) in Panama in 2007 to that in 2014?
Make the answer very short. 0.45. What is the ratio of the Claims(annual growth as % of broad money) of Uruguay in 2007 to that in 2014?
Your answer should be compact. 0.72. What is the ratio of the Claims(annual growth as % of broad money) in Albania in 2008 to that in 2009?
Your answer should be compact. 2.55. What is the ratio of the Claims(annual growth as % of broad money) in Macao in 2008 to that in 2009?
Make the answer very short. 2.2. What is the ratio of the Claims(annual growth as % of broad money) of Panama in 2008 to that in 2009?
Provide a short and direct response. 6.83. What is the ratio of the Claims(annual growth as % of broad money) in Albania in 2008 to that in 2010?
Make the answer very short. 2.51. What is the ratio of the Claims(annual growth as % of broad money) of Macao in 2008 to that in 2010?
Provide a succinct answer. 0.77. What is the ratio of the Claims(annual growth as % of broad money) of Panama in 2008 to that in 2010?
Offer a terse response. 1.09. What is the ratio of the Claims(annual growth as % of broad money) of Uruguay in 2008 to that in 2010?
Keep it short and to the point. 1.81. What is the ratio of the Claims(annual growth as % of broad money) of Albania in 2008 to that in 2011?
Provide a short and direct response. 2.49. What is the ratio of the Claims(annual growth as % of broad money) in Macao in 2008 to that in 2011?
Provide a short and direct response. 0.69. What is the ratio of the Claims(annual growth as % of broad money) in Panama in 2008 to that in 2011?
Give a very brief answer. 1.04. What is the ratio of the Claims(annual growth as % of broad money) of Uruguay in 2008 to that in 2011?
Provide a succinct answer. 2.21. What is the ratio of the Claims(annual growth as % of broad money) of Albania in 2008 to that in 2012?
Provide a short and direct response. 17.85. What is the ratio of the Claims(annual growth as % of broad money) of Macao in 2008 to that in 2012?
Make the answer very short. 0.97. What is the ratio of the Claims(annual growth as % of broad money) in Panama in 2008 to that in 2012?
Give a very brief answer. 0.98. What is the ratio of the Claims(annual growth as % of broad money) in Uruguay in 2008 to that in 2012?
Your response must be concise. 2.86. What is the ratio of the Claims(annual growth as % of broad money) of Macao in 2008 to that in 2013?
Keep it short and to the point. 0.68. What is the ratio of the Claims(annual growth as % of broad money) in Uruguay in 2008 to that in 2013?
Provide a succinct answer. 1.55. What is the ratio of the Claims(annual growth as % of broad money) of Albania in 2008 to that in 2014?
Your answer should be compact. 13.42. What is the ratio of the Claims(annual growth as % of broad money) in Macao in 2008 to that in 2014?
Provide a short and direct response. 0.57. What is the ratio of the Claims(annual growth as % of broad money) in Panama in 2008 to that in 2014?
Your response must be concise. 0.39. What is the ratio of the Claims(annual growth as % of broad money) in Uruguay in 2008 to that in 2014?
Keep it short and to the point. 2.14. What is the ratio of the Claims(annual growth as % of broad money) in Albania in 2009 to that in 2010?
Provide a short and direct response. 0.98. What is the ratio of the Claims(annual growth as % of broad money) of Macao in 2009 to that in 2010?
Offer a terse response. 0.35. What is the ratio of the Claims(annual growth as % of broad money) in Panama in 2009 to that in 2010?
Make the answer very short. 0.16. What is the ratio of the Claims(annual growth as % of broad money) of Albania in 2009 to that in 2011?
Offer a very short reply. 0.98. What is the ratio of the Claims(annual growth as % of broad money) in Macao in 2009 to that in 2011?
Provide a short and direct response. 0.32. What is the ratio of the Claims(annual growth as % of broad money) of Panama in 2009 to that in 2011?
Make the answer very short. 0.15. What is the ratio of the Claims(annual growth as % of broad money) of Albania in 2009 to that in 2012?
Your answer should be compact. 7.01. What is the ratio of the Claims(annual growth as % of broad money) of Macao in 2009 to that in 2012?
Keep it short and to the point. 0.44. What is the ratio of the Claims(annual growth as % of broad money) of Panama in 2009 to that in 2012?
Offer a terse response. 0.14. What is the ratio of the Claims(annual growth as % of broad money) in Macao in 2009 to that in 2013?
Offer a terse response. 0.31. What is the ratio of the Claims(annual growth as % of broad money) of Albania in 2009 to that in 2014?
Give a very brief answer. 5.27. What is the ratio of the Claims(annual growth as % of broad money) in Macao in 2009 to that in 2014?
Ensure brevity in your answer.  0.26. What is the ratio of the Claims(annual growth as % of broad money) of Panama in 2009 to that in 2014?
Make the answer very short. 0.06. What is the ratio of the Claims(annual growth as % of broad money) in Albania in 2010 to that in 2011?
Your answer should be very brief. 0.99. What is the ratio of the Claims(annual growth as % of broad money) of Macao in 2010 to that in 2011?
Offer a terse response. 0.91. What is the ratio of the Claims(annual growth as % of broad money) of Panama in 2010 to that in 2011?
Offer a terse response. 0.95. What is the ratio of the Claims(annual growth as % of broad money) of Uruguay in 2010 to that in 2011?
Your answer should be very brief. 1.22. What is the ratio of the Claims(annual growth as % of broad money) of Albania in 2010 to that in 2012?
Provide a short and direct response. 7.11. What is the ratio of the Claims(annual growth as % of broad money) in Macao in 2010 to that in 2012?
Provide a succinct answer. 1.26. What is the ratio of the Claims(annual growth as % of broad money) of Panama in 2010 to that in 2012?
Make the answer very short. 0.9. What is the ratio of the Claims(annual growth as % of broad money) in Uruguay in 2010 to that in 2012?
Your answer should be compact. 1.58. What is the ratio of the Claims(annual growth as % of broad money) in Macao in 2010 to that in 2013?
Provide a succinct answer. 0.89. What is the ratio of the Claims(annual growth as % of broad money) in Uruguay in 2010 to that in 2013?
Your response must be concise. 0.86. What is the ratio of the Claims(annual growth as % of broad money) in Albania in 2010 to that in 2014?
Your response must be concise. 5.35. What is the ratio of the Claims(annual growth as % of broad money) in Macao in 2010 to that in 2014?
Ensure brevity in your answer.  0.75. What is the ratio of the Claims(annual growth as % of broad money) in Panama in 2010 to that in 2014?
Your answer should be very brief. 0.36. What is the ratio of the Claims(annual growth as % of broad money) of Uruguay in 2010 to that in 2014?
Provide a succinct answer. 1.18. What is the ratio of the Claims(annual growth as % of broad money) of Albania in 2011 to that in 2012?
Keep it short and to the point. 7.16. What is the ratio of the Claims(annual growth as % of broad money) in Macao in 2011 to that in 2012?
Ensure brevity in your answer.  1.39. What is the ratio of the Claims(annual growth as % of broad money) in Panama in 2011 to that in 2012?
Provide a succinct answer. 0.94. What is the ratio of the Claims(annual growth as % of broad money) of Uruguay in 2011 to that in 2012?
Offer a very short reply. 1.3. What is the ratio of the Claims(annual growth as % of broad money) of Macao in 2011 to that in 2013?
Ensure brevity in your answer.  0.98. What is the ratio of the Claims(annual growth as % of broad money) of Uruguay in 2011 to that in 2013?
Ensure brevity in your answer.  0.7. What is the ratio of the Claims(annual growth as % of broad money) in Albania in 2011 to that in 2014?
Your answer should be very brief. 5.38. What is the ratio of the Claims(annual growth as % of broad money) in Macao in 2011 to that in 2014?
Offer a very short reply. 0.83. What is the ratio of the Claims(annual growth as % of broad money) of Panama in 2011 to that in 2014?
Make the answer very short. 0.37. What is the ratio of the Claims(annual growth as % of broad money) in Uruguay in 2011 to that in 2014?
Give a very brief answer. 0.97. What is the ratio of the Claims(annual growth as % of broad money) in Macao in 2012 to that in 2013?
Offer a very short reply. 0.7. What is the ratio of the Claims(annual growth as % of broad money) in Uruguay in 2012 to that in 2013?
Your response must be concise. 0.54. What is the ratio of the Claims(annual growth as % of broad money) in Albania in 2012 to that in 2014?
Offer a very short reply. 0.75. What is the ratio of the Claims(annual growth as % of broad money) of Macao in 2012 to that in 2014?
Your answer should be very brief. 0.59. What is the ratio of the Claims(annual growth as % of broad money) in Panama in 2012 to that in 2014?
Ensure brevity in your answer.  0.4. What is the ratio of the Claims(annual growth as % of broad money) in Uruguay in 2012 to that in 2014?
Offer a very short reply. 0.75. What is the ratio of the Claims(annual growth as % of broad money) in Macao in 2013 to that in 2014?
Provide a short and direct response. 0.85. What is the ratio of the Claims(annual growth as % of broad money) in Uruguay in 2013 to that in 2014?
Keep it short and to the point. 1.38. What is the difference between the highest and the second highest Claims(annual growth as % of broad money) in Albania?
Offer a very short reply. 1.87. What is the difference between the highest and the second highest Claims(annual growth as % of broad money) of Macao?
Give a very brief answer. 2.85. What is the difference between the highest and the second highest Claims(annual growth as % of broad money) of Panama?
Give a very brief answer. 22.72. What is the difference between the highest and the second highest Claims(annual growth as % of broad money) in Uruguay?
Offer a terse response. 7.71. What is the difference between the highest and the lowest Claims(annual growth as % of broad money) in Albania?
Your response must be concise. 14.15. What is the difference between the highest and the lowest Claims(annual growth as % of broad money) in Macao?
Give a very brief answer. 13.71. What is the difference between the highest and the lowest Claims(annual growth as % of broad money) of Panama?
Offer a terse response. 41.32. What is the difference between the highest and the lowest Claims(annual growth as % of broad money) in Uruguay?
Ensure brevity in your answer.  21.74. 